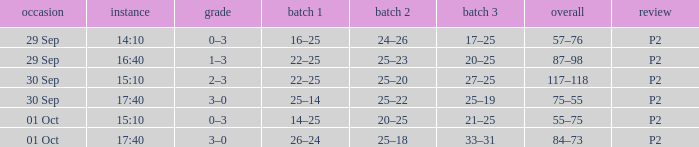What Score has a time of 14:10? 0–3. 